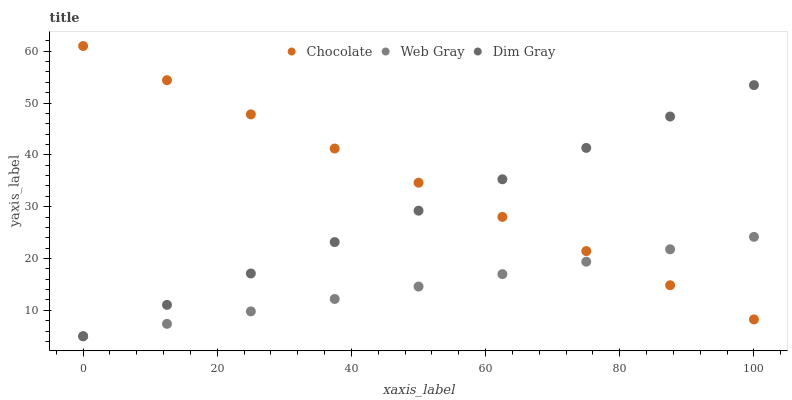Does Web Gray have the minimum area under the curve?
Answer yes or no. Yes. Does Chocolate have the maximum area under the curve?
Answer yes or no. Yes. Does Chocolate have the minimum area under the curve?
Answer yes or no. No. Does Web Gray have the maximum area under the curve?
Answer yes or no. No. Is Dim Gray the smoothest?
Answer yes or no. Yes. Is Chocolate the roughest?
Answer yes or no. Yes. Is Chocolate the smoothest?
Answer yes or no. No. Is Web Gray the roughest?
Answer yes or no. No. Does Dim Gray have the lowest value?
Answer yes or no. Yes. Does Chocolate have the lowest value?
Answer yes or no. No. Does Chocolate have the highest value?
Answer yes or no. Yes. Does Web Gray have the highest value?
Answer yes or no. No. Does Web Gray intersect Chocolate?
Answer yes or no. Yes. Is Web Gray less than Chocolate?
Answer yes or no. No. Is Web Gray greater than Chocolate?
Answer yes or no. No. 